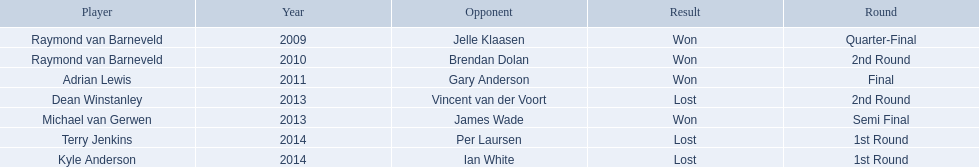Who were all the players? Raymond van Barneveld, Raymond van Barneveld, Adrian Lewis, Dean Winstanley, Michael van Gerwen, Terry Jenkins, Kyle Anderson. Which of these played in 2014? Terry Jenkins, Kyle Anderson. Who were their opponents? Per Laursen, Ian White. Which of these beat terry jenkins? Per Laursen. 